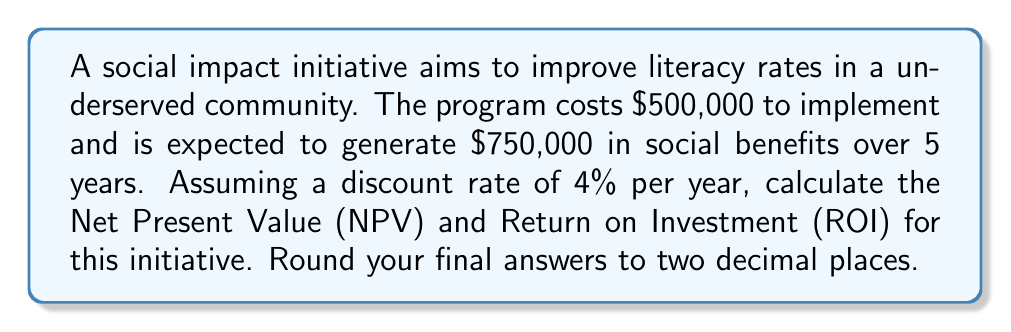Can you answer this question? To solve this problem, we need to follow these steps:

1. Calculate the Present Value (PV) of the benefits
2. Calculate the Net Present Value (NPV)
3. Calculate the Return on Investment (ROI)

Step 1: Calculate the Present Value (PV) of the benefits

The Present Value formula is:

$$ PV = \frac{FV}{(1+r)^n} $$

Where:
- FV = Future Value ($750,000)
- r = Discount rate (4% or 0.04)
- n = Number of years (5)

$$ PV = \frac{750,000}{(1+0.04)^5} = \frac{750,000}{1.2166529} = 616,444.99 $$

Step 2: Calculate the Net Present Value (NPV)

NPV is the difference between the Present Value of benefits and the initial investment:

$$ NPV = PV - Initial Investment $$
$$ NPV = 616,444.99 - 500,000 = 116,444.99 $$

Step 3: Calculate the Return on Investment (ROI)

ROI is calculated as:

$$ ROI = \frac{NPV}{Initial Investment} \times 100\% $$

$$ ROI = \frac{116,444.99}{500,000} \times 100\% = 23.29\% $$
Answer: Net Present Value (NPV): $116,444.99
Return on Investment (ROI): 23.29% 